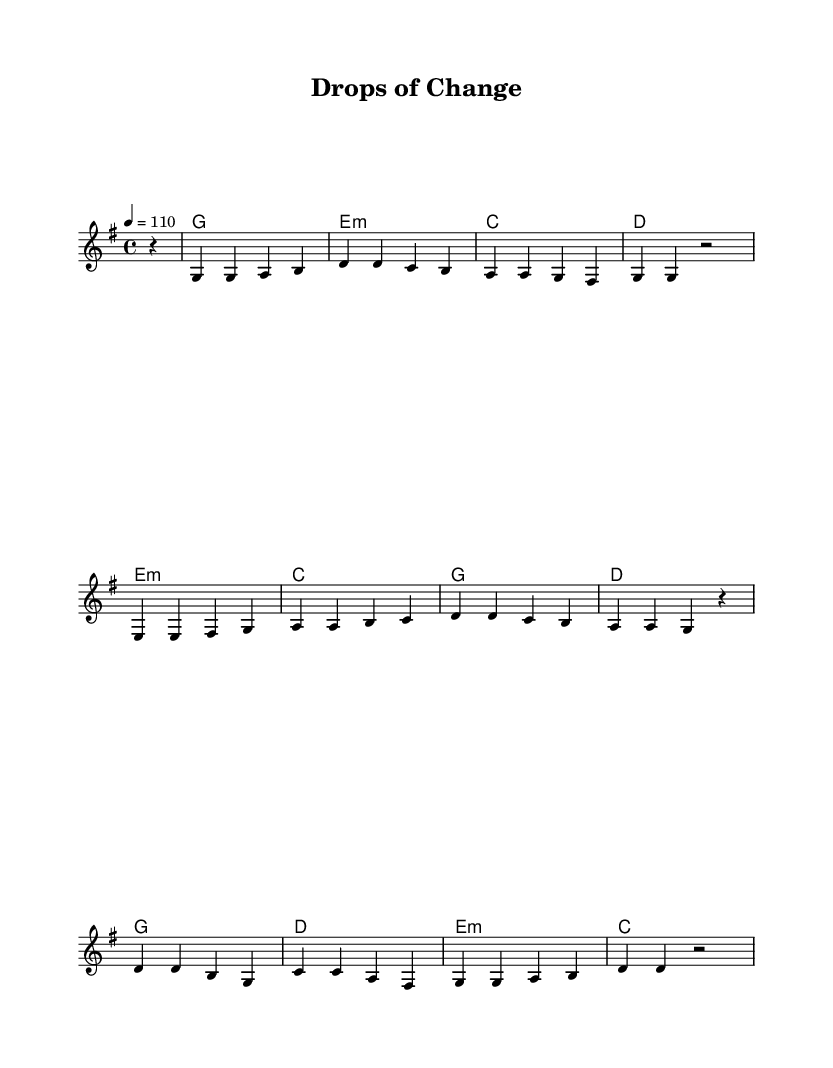What is the key signature of this music? The key signature is G major, which has one sharp (F#). You can identify it at the beginning of the sheet music, where the key signature is displayed.
Answer: G major What is the time signature of this music? The time signature is 4/4, which indicates there are four beats in each measure and the quarter note gets one beat. This is shown near the beginning of the score.
Answer: 4/4 What is the tempo marking for this piece? The tempo marking is 110 beats per minute, indicated in the score right after the time signature. This indicates how fast the piece should be played.
Answer: 110 How many measures are in the Chorus section? The Chorus section consists of four measures, as seen in the notation. Each section is separated by the vertical lines that represent measures, and counting them gives four distinct measures.
Answer: 4 What chord is played in the first measure of the Verse? The chord played in the first measure of the Verse is G major, which is shown in the chord names section above the melody. It identifies the harmonization for that specific measure.
Answer: G Which part of the song starts with the note E? The Pre-Chorus section begins with the note E, visible in the melody line, which leads into the following notes. Identifying the note progression shows this clearly.
Answer: Pre-Chorus How many times is the note D played in the Chorus? The note D is played five times in the Chorus, which can be determined by examining the melody line in that section and counting each occurrence of the note within the specified measures.
Answer: 5 